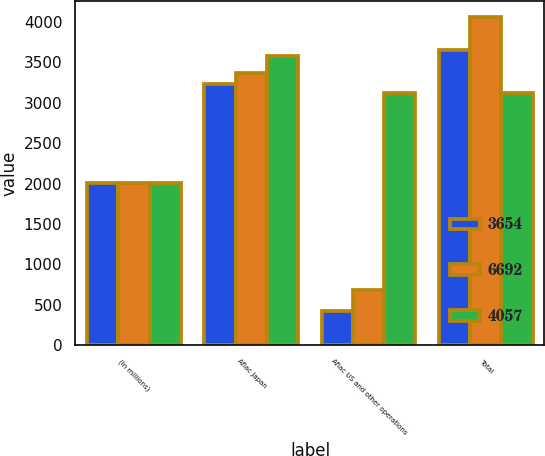Convert chart to OTSL. <chart><loc_0><loc_0><loc_500><loc_500><stacked_bar_chart><ecel><fcel>(In millions)<fcel>Aflac Japan<fcel>Aflac US and other operations<fcel>Total<nl><fcel>3654<fcel>2007<fcel>3231<fcel>423<fcel>3654<nl><fcel>6692<fcel>2006<fcel>3372<fcel>685<fcel>4057<nl><fcel>4057<fcel>2005<fcel>3574<fcel>3118<fcel>3118<nl></chart> 